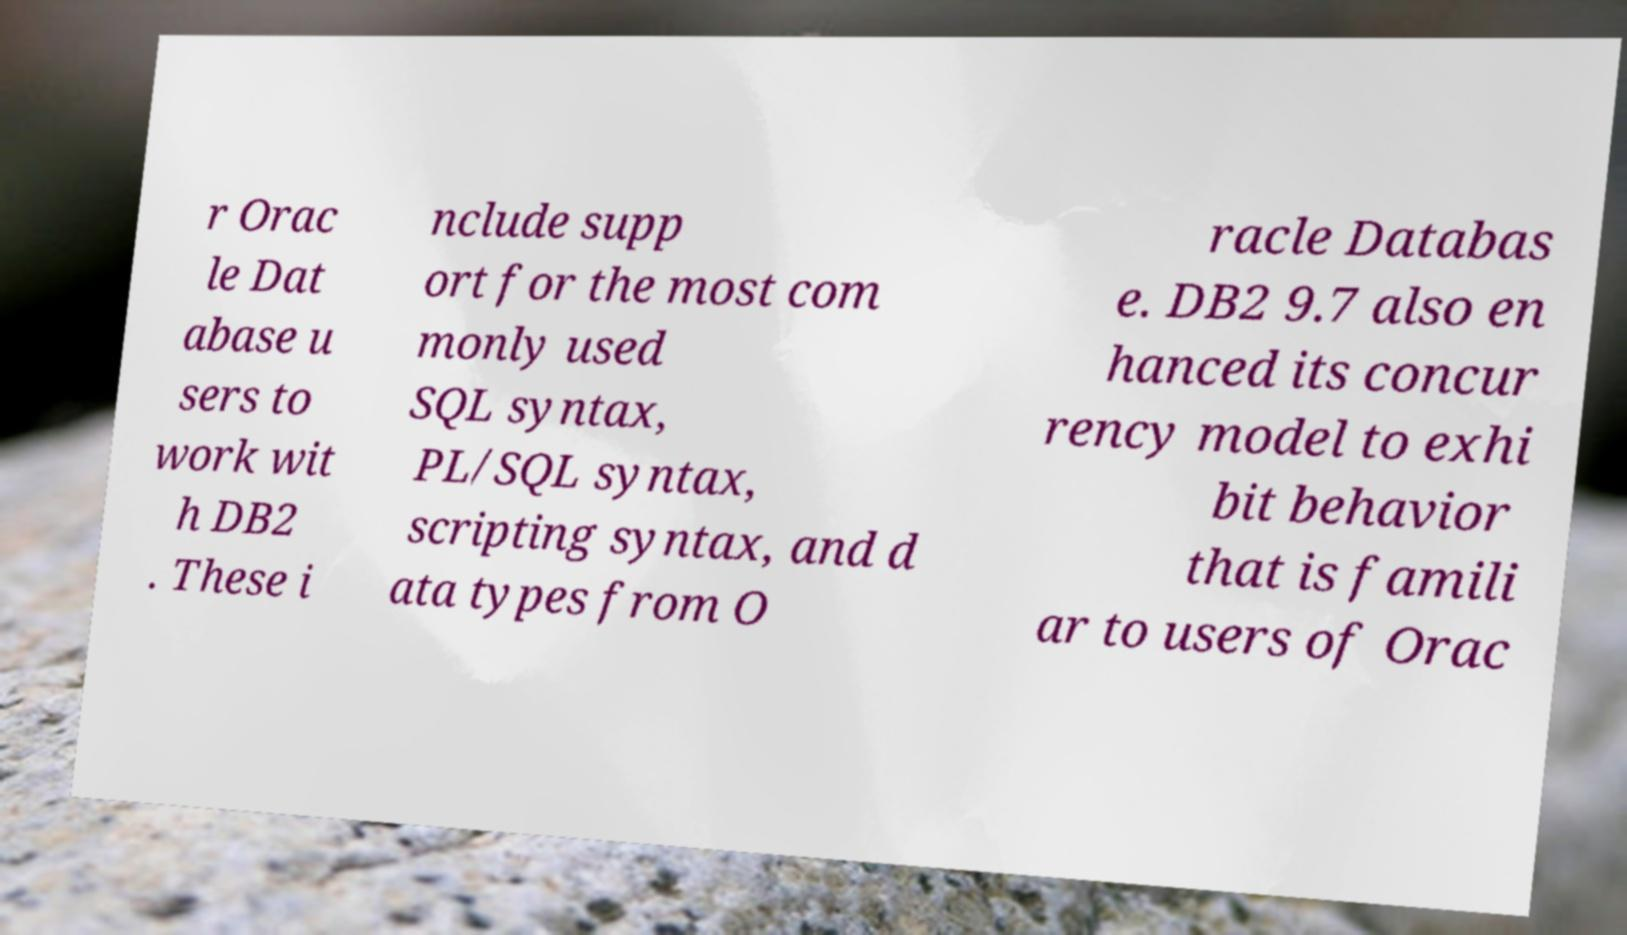Please identify and transcribe the text found in this image. r Orac le Dat abase u sers to work wit h DB2 . These i nclude supp ort for the most com monly used SQL syntax, PL/SQL syntax, scripting syntax, and d ata types from O racle Databas e. DB2 9.7 also en hanced its concur rency model to exhi bit behavior that is famili ar to users of Orac 